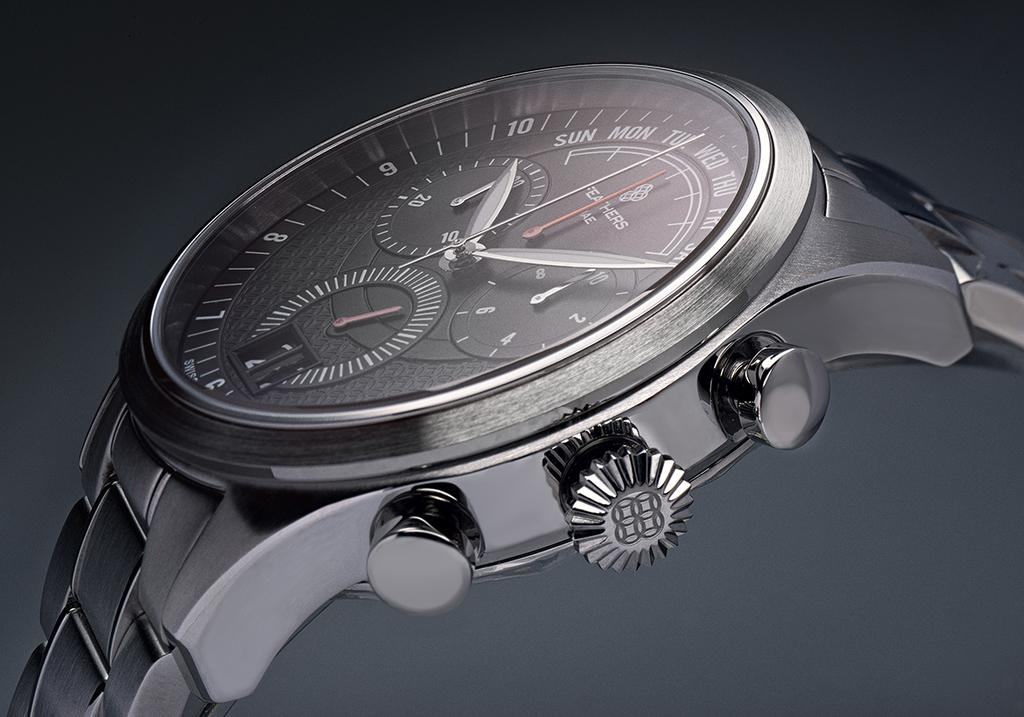<image>
Relay a brief, clear account of the picture shown. A watch with the day  and the time around 10:10 